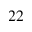<formula> <loc_0><loc_0><loc_500><loc_500>^ { 2 2 }</formula> 